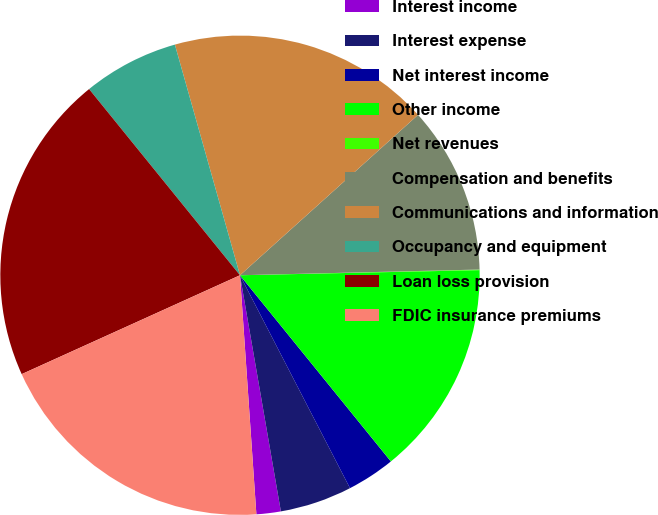Convert chart. <chart><loc_0><loc_0><loc_500><loc_500><pie_chart><fcel>Interest income<fcel>Interest expense<fcel>Net interest income<fcel>Other income<fcel>Net revenues<fcel>Compensation and benefits<fcel>Communications and information<fcel>Occupancy and equipment<fcel>Loan loss provision<fcel>FDIC insurance premiums<nl><fcel>1.64%<fcel>4.86%<fcel>3.25%<fcel>14.5%<fcel>0.04%<fcel>11.29%<fcel>17.71%<fcel>6.46%<fcel>20.93%<fcel>19.32%<nl></chart> 